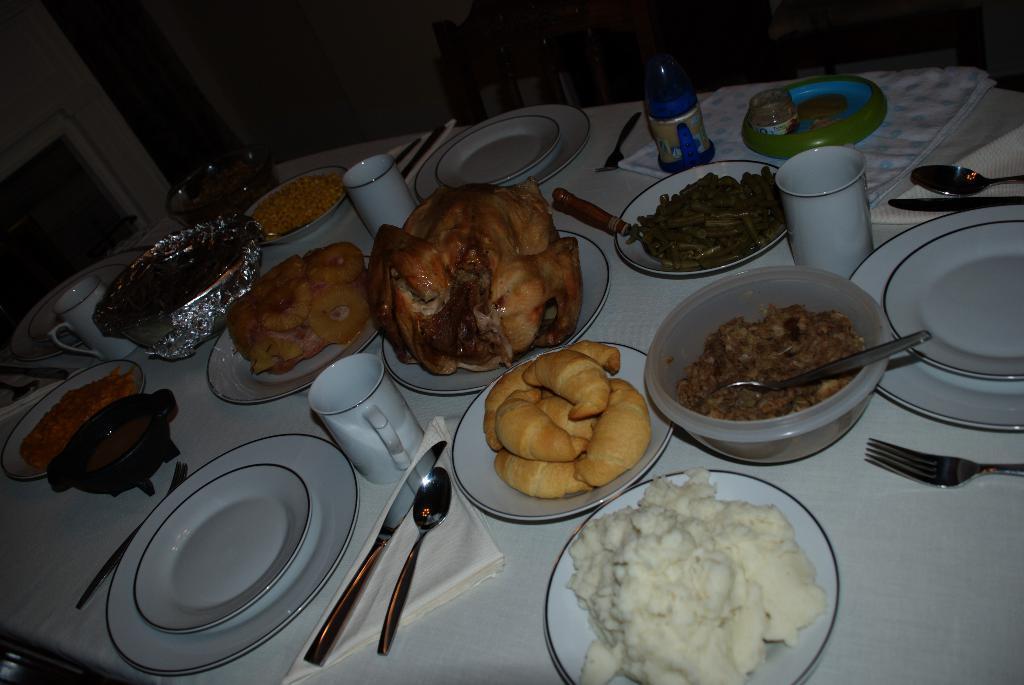Describe this image in one or two sentences. In this image I can see there are lot of food items, forks, spoons and glasses on this dining table. At the top there are chairs. 